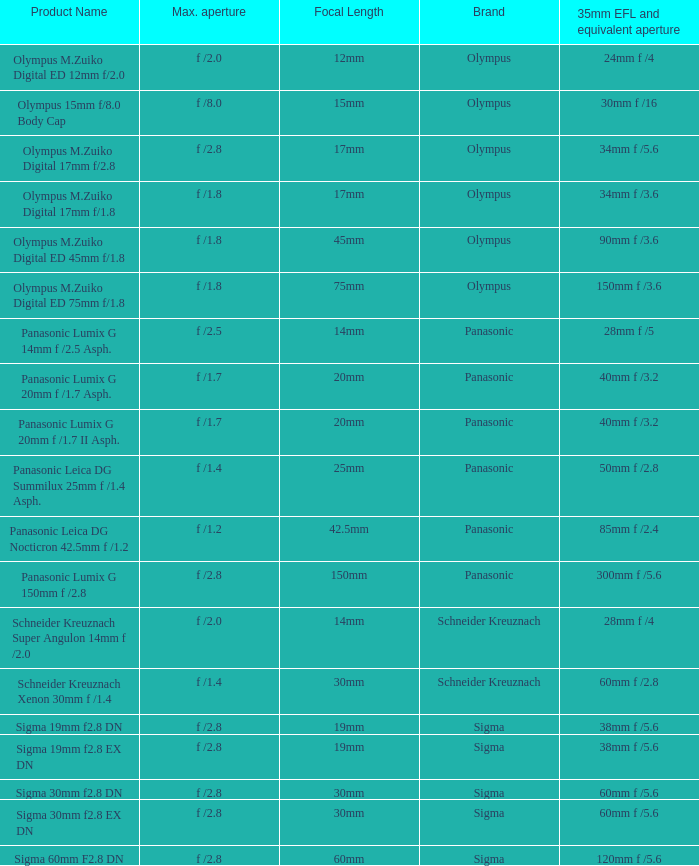What is the maximum aperture of the lens(es) with a focal length of 20mm? F /1.7, f /1.7. 